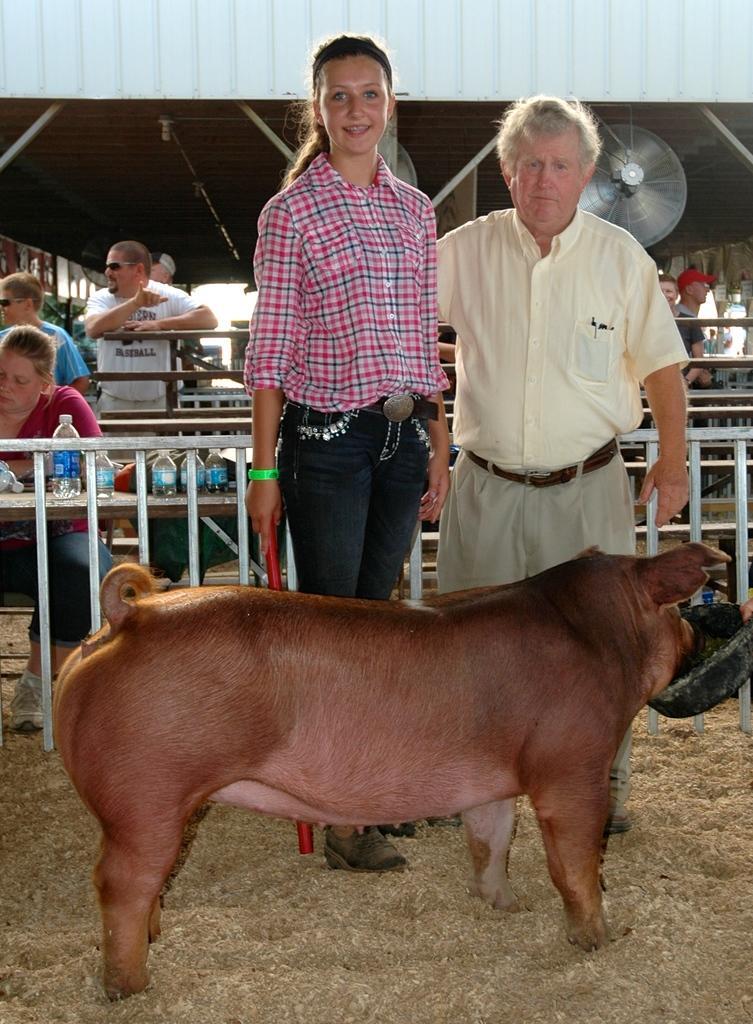Could you give a brief overview of what you see in this image? This image is taken outdoors. At the bottom of the image there is grass on the ground. In the middle of the image there is a pig standing on the ground. A man and a girl are standing on the ground. A girl is holding a stick in her hand. In the background a woman is sitting in the chair and a few are standing. There are many fences and railings. There are a few tables with a few things on them. At the top of the image there is a roof and there are a few iron bars and there is a fan. 